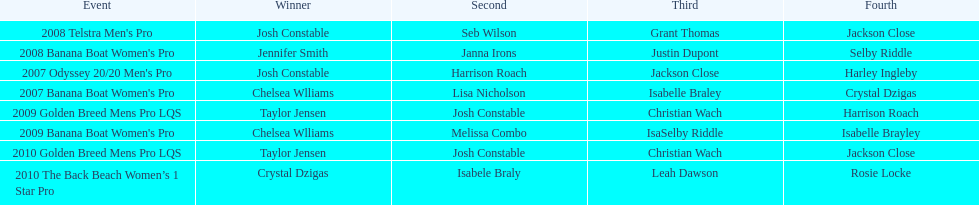Who was the leading performer in the 2008 telstra men's pro? Josh Constable. 